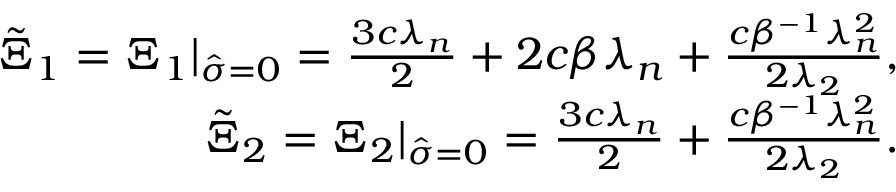Convert formula to latex. <formula><loc_0><loc_0><loc_500><loc_500>\begin{array} { r } { \tilde { \Xi } _ { 1 } = \Xi _ { 1 } | _ { \hat { \sigma } = 0 } = \frac { 3 c \lambda _ { n } } { 2 } + { 2 c \beta \lambda _ { n } } + \frac { c \beta ^ { - 1 } \lambda _ { n } ^ { 2 } } { 2 \lambda _ { 2 } } , } \\ { \tilde { \Xi } _ { 2 } = \Xi _ { 2 } | _ { \hat { \sigma } = 0 } = \frac { 3 c \lambda _ { n } } { 2 } + \frac { c \beta ^ { - 1 } \lambda _ { n } ^ { 2 } } { 2 \lambda _ { 2 } } . } \end{array}</formula> 